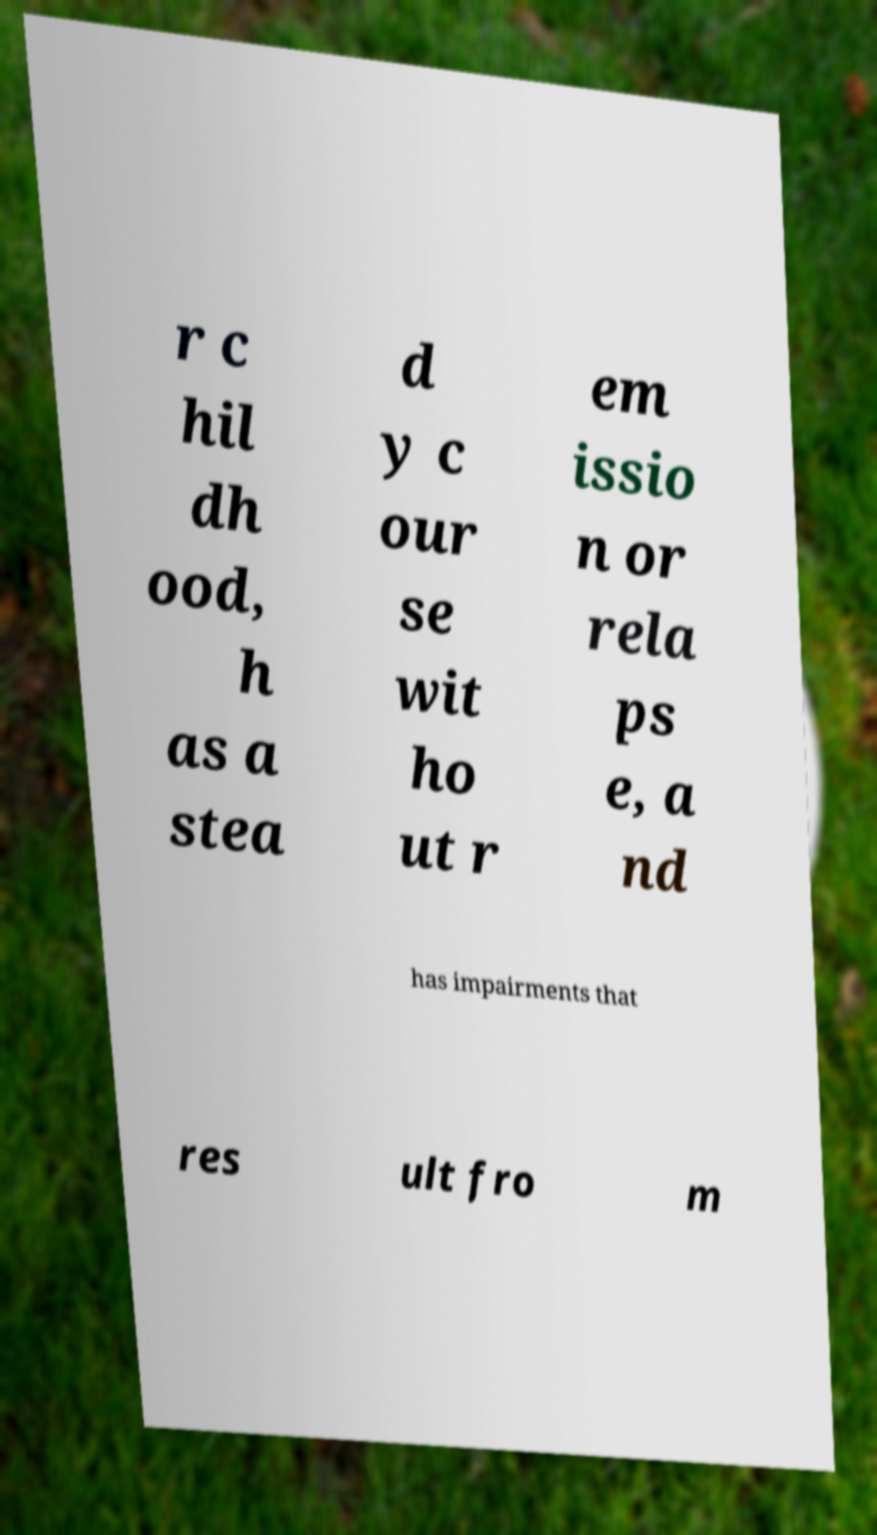Could you extract and type out the text from this image? r c hil dh ood, h as a stea d y c our se wit ho ut r em issio n or rela ps e, a nd has impairments that res ult fro m 